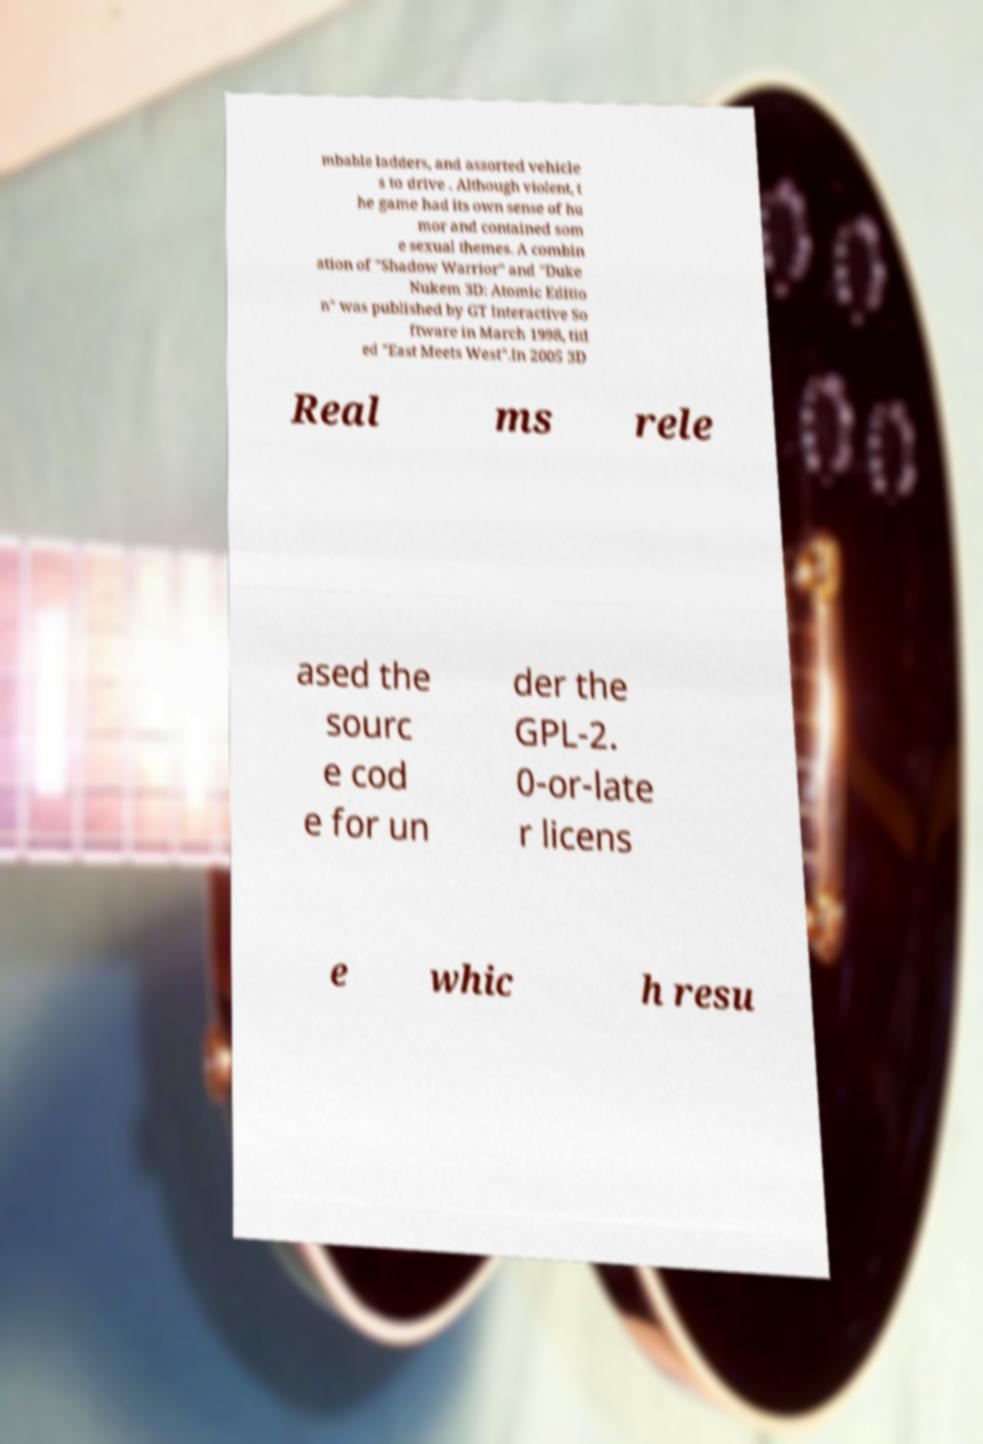What messages or text are displayed in this image? I need them in a readable, typed format. mbable ladders, and assorted vehicle s to drive . Although violent, t he game had its own sense of hu mor and contained som e sexual themes. A combin ation of "Shadow Warrior" and "Duke Nukem 3D: Atomic Editio n" was published by GT Interactive So ftware in March 1998, titl ed "East Meets West".In 2005 3D Real ms rele ased the sourc e cod e for un der the GPL-2. 0-or-late r licens e whic h resu 